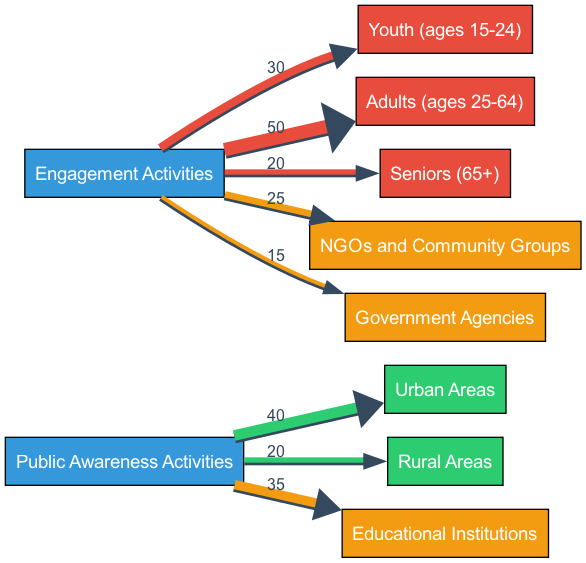What is the total value of public awareness activities directed towards urban areas? The diagram shows a direct link from 'Public Awareness Activities' to 'Urban Areas' with a value of 40. This is the total value for that specific pathway in the diagram.
Answer: 40 Which demographic has the highest engagement activity value? By examining the links related to 'Engagement Activities', the highest value is directed towards 'Adults (ages 25-64)' with a value of 50.
Answer: 50 How many different demographic nodes are shown in the diagram? The diagram includes three demographic nodes: 'Youth (ages 15-24)', 'Adults (ages 25-64)', and 'Seniors (65+)', totaling three nodes.
Answer: 3 What is the total engagement activity value for seniors? Looking at the link from 'Engagement Activities' to 'Seniors (65+)', the value is 20, which is the total value for that pathway.
Answer: 20 Which region has the least value of public awareness activities? The link from 'Public Awareness Activities' to 'Rural Areas' has a value of 20, which is less compared to the value of urban areas at 40, making rural areas the lowest.
Answer: Rural Areas What is the combined engagement activity value for government agencies and NGOs? The values for 'Engagement Activities' leading to 'Government Agencies' is 15 and leading to 'NGOs and Community Groups' is 25. Adding these together yields a total of 40.
Answer: 40 How many links are there from the public awareness activities to other nodes? The diagram shows three outward links from 'Public Awareness Activities' to 'Urban Areas', 'Rural Areas', and 'Educational Institutions', totaling three links.
Answer: 3 What is the proportion of engagement activities directed towards youth compared to adults? The values indicate 30 directed towards 'Youth (ages 15-24)' and 50 towards 'Adults (ages 25-64)', creating a proportion of 30:50 or 3:5.
Answer: 3:5 